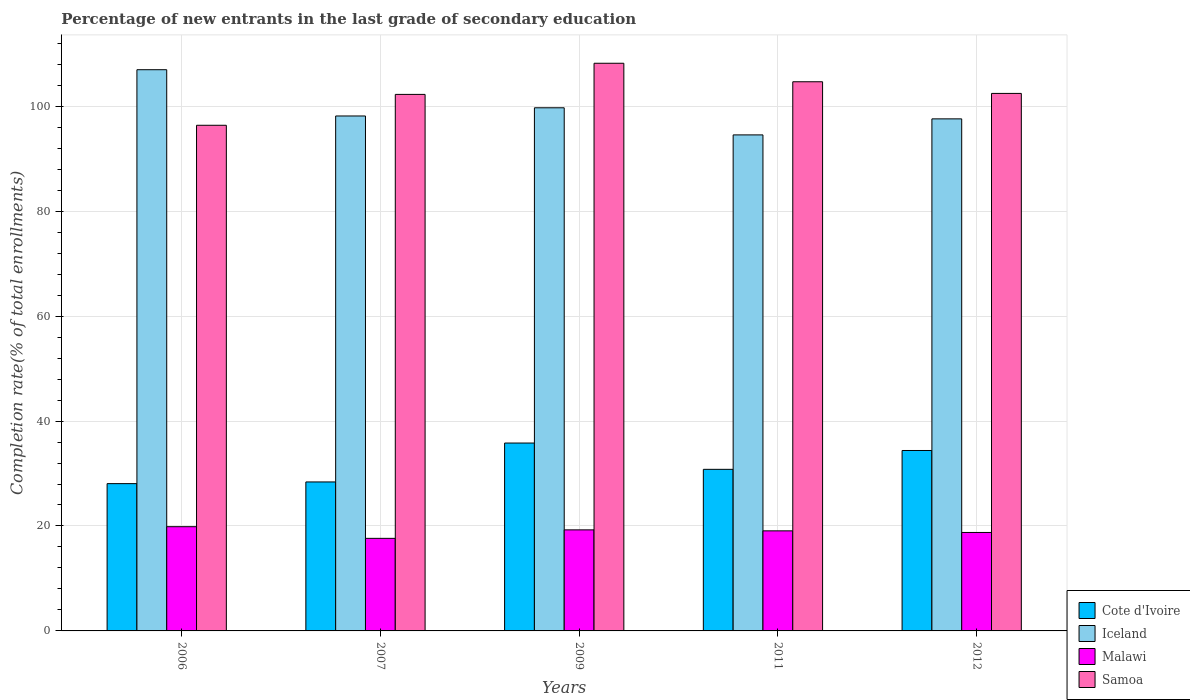How many groups of bars are there?
Offer a very short reply. 5. How many bars are there on the 4th tick from the left?
Your answer should be very brief. 4. What is the label of the 3rd group of bars from the left?
Keep it short and to the point. 2009. What is the percentage of new entrants in Iceland in 2006?
Your answer should be very brief. 106.96. Across all years, what is the maximum percentage of new entrants in Cote d'Ivoire?
Your answer should be very brief. 35.81. Across all years, what is the minimum percentage of new entrants in Malawi?
Your answer should be compact. 17.64. In which year was the percentage of new entrants in Cote d'Ivoire maximum?
Keep it short and to the point. 2009. What is the total percentage of new entrants in Malawi in the graph?
Offer a terse response. 94.61. What is the difference between the percentage of new entrants in Iceland in 2006 and that in 2007?
Offer a terse response. 8.82. What is the difference between the percentage of new entrants in Iceland in 2007 and the percentage of new entrants in Cote d'Ivoire in 2012?
Your answer should be compact. 63.76. What is the average percentage of new entrants in Samoa per year?
Give a very brief answer. 102.79. In the year 2009, what is the difference between the percentage of new entrants in Samoa and percentage of new entrants in Malawi?
Keep it short and to the point. 88.93. In how many years, is the percentage of new entrants in Cote d'Ivoire greater than 88 %?
Your answer should be very brief. 0. What is the ratio of the percentage of new entrants in Malawi in 2006 to that in 2007?
Offer a terse response. 1.13. Is the percentage of new entrants in Samoa in 2006 less than that in 2007?
Make the answer very short. Yes. What is the difference between the highest and the second highest percentage of new entrants in Cote d'Ivoire?
Ensure brevity in your answer.  1.42. What is the difference between the highest and the lowest percentage of new entrants in Iceland?
Make the answer very short. 12.42. What does the 3rd bar from the left in 2006 represents?
Provide a succinct answer. Malawi. What does the 4th bar from the right in 2007 represents?
Ensure brevity in your answer.  Cote d'Ivoire. Is it the case that in every year, the sum of the percentage of new entrants in Iceland and percentage of new entrants in Malawi is greater than the percentage of new entrants in Samoa?
Offer a terse response. Yes. How many bars are there?
Provide a succinct answer. 20. Are all the bars in the graph horizontal?
Make the answer very short. No. How many years are there in the graph?
Make the answer very short. 5. Are the values on the major ticks of Y-axis written in scientific E-notation?
Offer a very short reply. No. Does the graph contain grids?
Make the answer very short. Yes. Where does the legend appear in the graph?
Offer a very short reply. Bottom right. What is the title of the graph?
Keep it short and to the point. Percentage of new entrants in the last grade of secondary education. Does "Paraguay" appear as one of the legend labels in the graph?
Make the answer very short. No. What is the label or title of the X-axis?
Offer a very short reply. Years. What is the label or title of the Y-axis?
Your response must be concise. Completion rate(% of total enrollments). What is the Completion rate(% of total enrollments) in Cote d'Ivoire in 2006?
Offer a terse response. 28.07. What is the Completion rate(% of total enrollments) of Iceland in 2006?
Your response must be concise. 106.96. What is the Completion rate(% of total enrollments) in Malawi in 2006?
Give a very brief answer. 19.86. What is the Completion rate(% of total enrollments) in Samoa in 2006?
Provide a short and direct response. 96.37. What is the Completion rate(% of total enrollments) in Cote d'Ivoire in 2007?
Ensure brevity in your answer.  28.39. What is the Completion rate(% of total enrollments) of Iceland in 2007?
Offer a terse response. 98.14. What is the Completion rate(% of total enrollments) in Malawi in 2007?
Offer a very short reply. 17.64. What is the Completion rate(% of total enrollments) of Samoa in 2007?
Provide a succinct answer. 102.26. What is the Completion rate(% of total enrollments) of Cote d'Ivoire in 2009?
Give a very brief answer. 35.81. What is the Completion rate(% of total enrollments) of Iceland in 2009?
Make the answer very short. 99.7. What is the Completion rate(% of total enrollments) of Malawi in 2009?
Your answer should be very brief. 19.26. What is the Completion rate(% of total enrollments) of Samoa in 2009?
Offer a terse response. 108.19. What is the Completion rate(% of total enrollments) in Cote d'Ivoire in 2011?
Keep it short and to the point. 30.8. What is the Completion rate(% of total enrollments) of Iceland in 2011?
Offer a terse response. 94.54. What is the Completion rate(% of total enrollments) in Malawi in 2011?
Ensure brevity in your answer.  19.07. What is the Completion rate(% of total enrollments) in Samoa in 2011?
Offer a terse response. 104.66. What is the Completion rate(% of total enrollments) in Cote d'Ivoire in 2012?
Your answer should be compact. 34.39. What is the Completion rate(% of total enrollments) in Iceland in 2012?
Offer a terse response. 97.59. What is the Completion rate(% of total enrollments) of Malawi in 2012?
Provide a succinct answer. 18.77. What is the Completion rate(% of total enrollments) in Samoa in 2012?
Your answer should be compact. 102.44. Across all years, what is the maximum Completion rate(% of total enrollments) of Cote d'Ivoire?
Provide a short and direct response. 35.81. Across all years, what is the maximum Completion rate(% of total enrollments) of Iceland?
Your response must be concise. 106.96. Across all years, what is the maximum Completion rate(% of total enrollments) in Malawi?
Offer a terse response. 19.86. Across all years, what is the maximum Completion rate(% of total enrollments) of Samoa?
Provide a short and direct response. 108.19. Across all years, what is the minimum Completion rate(% of total enrollments) of Cote d'Ivoire?
Offer a terse response. 28.07. Across all years, what is the minimum Completion rate(% of total enrollments) of Iceland?
Provide a succinct answer. 94.54. Across all years, what is the minimum Completion rate(% of total enrollments) of Malawi?
Offer a terse response. 17.64. Across all years, what is the minimum Completion rate(% of total enrollments) in Samoa?
Provide a succinct answer. 96.37. What is the total Completion rate(% of total enrollments) of Cote d'Ivoire in the graph?
Provide a short and direct response. 157.46. What is the total Completion rate(% of total enrollments) in Iceland in the graph?
Provide a short and direct response. 496.94. What is the total Completion rate(% of total enrollments) of Malawi in the graph?
Give a very brief answer. 94.61. What is the total Completion rate(% of total enrollments) in Samoa in the graph?
Your answer should be very brief. 513.93. What is the difference between the Completion rate(% of total enrollments) of Cote d'Ivoire in 2006 and that in 2007?
Your answer should be very brief. -0.32. What is the difference between the Completion rate(% of total enrollments) in Iceland in 2006 and that in 2007?
Your response must be concise. 8.82. What is the difference between the Completion rate(% of total enrollments) of Malawi in 2006 and that in 2007?
Make the answer very short. 2.22. What is the difference between the Completion rate(% of total enrollments) in Samoa in 2006 and that in 2007?
Offer a very short reply. -5.88. What is the difference between the Completion rate(% of total enrollments) in Cote d'Ivoire in 2006 and that in 2009?
Your response must be concise. -7.74. What is the difference between the Completion rate(% of total enrollments) in Iceland in 2006 and that in 2009?
Provide a short and direct response. 7.26. What is the difference between the Completion rate(% of total enrollments) of Malawi in 2006 and that in 2009?
Your response must be concise. 0.6. What is the difference between the Completion rate(% of total enrollments) in Samoa in 2006 and that in 2009?
Offer a very short reply. -11.82. What is the difference between the Completion rate(% of total enrollments) in Cote d'Ivoire in 2006 and that in 2011?
Provide a succinct answer. -2.73. What is the difference between the Completion rate(% of total enrollments) in Iceland in 2006 and that in 2011?
Give a very brief answer. 12.42. What is the difference between the Completion rate(% of total enrollments) of Malawi in 2006 and that in 2011?
Offer a terse response. 0.79. What is the difference between the Completion rate(% of total enrollments) in Samoa in 2006 and that in 2011?
Ensure brevity in your answer.  -8.29. What is the difference between the Completion rate(% of total enrollments) in Cote d'Ivoire in 2006 and that in 2012?
Provide a short and direct response. -6.32. What is the difference between the Completion rate(% of total enrollments) of Iceland in 2006 and that in 2012?
Offer a very short reply. 9.37. What is the difference between the Completion rate(% of total enrollments) in Malawi in 2006 and that in 2012?
Ensure brevity in your answer.  1.1. What is the difference between the Completion rate(% of total enrollments) in Samoa in 2006 and that in 2012?
Your answer should be compact. -6.07. What is the difference between the Completion rate(% of total enrollments) of Cote d'Ivoire in 2007 and that in 2009?
Make the answer very short. -7.41. What is the difference between the Completion rate(% of total enrollments) of Iceland in 2007 and that in 2009?
Your answer should be very brief. -1.56. What is the difference between the Completion rate(% of total enrollments) in Malawi in 2007 and that in 2009?
Keep it short and to the point. -1.62. What is the difference between the Completion rate(% of total enrollments) of Samoa in 2007 and that in 2009?
Make the answer very short. -5.94. What is the difference between the Completion rate(% of total enrollments) of Cote d'Ivoire in 2007 and that in 2011?
Make the answer very short. -2.4. What is the difference between the Completion rate(% of total enrollments) of Iceland in 2007 and that in 2011?
Your answer should be very brief. 3.61. What is the difference between the Completion rate(% of total enrollments) in Malawi in 2007 and that in 2011?
Give a very brief answer. -1.43. What is the difference between the Completion rate(% of total enrollments) in Samoa in 2007 and that in 2011?
Make the answer very short. -2.41. What is the difference between the Completion rate(% of total enrollments) of Cote d'Ivoire in 2007 and that in 2012?
Your response must be concise. -5.99. What is the difference between the Completion rate(% of total enrollments) of Iceland in 2007 and that in 2012?
Your answer should be very brief. 0.55. What is the difference between the Completion rate(% of total enrollments) in Malawi in 2007 and that in 2012?
Provide a short and direct response. -1.12. What is the difference between the Completion rate(% of total enrollments) in Samoa in 2007 and that in 2012?
Provide a succinct answer. -0.19. What is the difference between the Completion rate(% of total enrollments) of Cote d'Ivoire in 2009 and that in 2011?
Offer a terse response. 5.01. What is the difference between the Completion rate(% of total enrollments) in Iceland in 2009 and that in 2011?
Provide a succinct answer. 5.17. What is the difference between the Completion rate(% of total enrollments) of Malawi in 2009 and that in 2011?
Your response must be concise. 0.19. What is the difference between the Completion rate(% of total enrollments) in Samoa in 2009 and that in 2011?
Your response must be concise. 3.53. What is the difference between the Completion rate(% of total enrollments) of Cote d'Ivoire in 2009 and that in 2012?
Provide a short and direct response. 1.42. What is the difference between the Completion rate(% of total enrollments) in Iceland in 2009 and that in 2012?
Your answer should be compact. 2.11. What is the difference between the Completion rate(% of total enrollments) in Malawi in 2009 and that in 2012?
Your answer should be very brief. 0.49. What is the difference between the Completion rate(% of total enrollments) of Samoa in 2009 and that in 2012?
Your response must be concise. 5.75. What is the difference between the Completion rate(% of total enrollments) of Cote d'Ivoire in 2011 and that in 2012?
Keep it short and to the point. -3.59. What is the difference between the Completion rate(% of total enrollments) in Iceland in 2011 and that in 2012?
Your response must be concise. -3.06. What is the difference between the Completion rate(% of total enrollments) of Malawi in 2011 and that in 2012?
Your answer should be very brief. 0.31. What is the difference between the Completion rate(% of total enrollments) in Samoa in 2011 and that in 2012?
Provide a short and direct response. 2.22. What is the difference between the Completion rate(% of total enrollments) of Cote d'Ivoire in 2006 and the Completion rate(% of total enrollments) of Iceland in 2007?
Your answer should be compact. -70.07. What is the difference between the Completion rate(% of total enrollments) of Cote d'Ivoire in 2006 and the Completion rate(% of total enrollments) of Malawi in 2007?
Offer a terse response. 10.43. What is the difference between the Completion rate(% of total enrollments) in Cote d'Ivoire in 2006 and the Completion rate(% of total enrollments) in Samoa in 2007?
Your answer should be very brief. -74.18. What is the difference between the Completion rate(% of total enrollments) of Iceland in 2006 and the Completion rate(% of total enrollments) of Malawi in 2007?
Keep it short and to the point. 89.32. What is the difference between the Completion rate(% of total enrollments) of Iceland in 2006 and the Completion rate(% of total enrollments) of Samoa in 2007?
Provide a short and direct response. 4.7. What is the difference between the Completion rate(% of total enrollments) of Malawi in 2006 and the Completion rate(% of total enrollments) of Samoa in 2007?
Offer a very short reply. -82.39. What is the difference between the Completion rate(% of total enrollments) in Cote d'Ivoire in 2006 and the Completion rate(% of total enrollments) in Iceland in 2009?
Provide a short and direct response. -71.63. What is the difference between the Completion rate(% of total enrollments) of Cote d'Ivoire in 2006 and the Completion rate(% of total enrollments) of Malawi in 2009?
Your answer should be compact. 8.81. What is the difference between the Completion rate(% of total enrollments) of Cote d'Ivoire in 2006 and the Completion rate(% of total enrollments) of Samoa in 2009?
Give a very brief answer. -80.12. What is the difference between the Completion rate(% of total enrollments) in Iceland in 2006 and the Completion rate(% of total enrollments) in Malawi in 2009?
Your answer should be very brief. 87.7. What is the difference between the Completion rate(% of total enrollments) of Iceland in 2006 and the Completion rate(% of total enrollments) of Samoa in 2009?
Offer a terse response. -1.23. What is the difference between the Completion rate(% of total enrollments) of Malawi in 2006 and the Completion rate(% of total enrollments) of Samoa in 2009?
Your answer should be very brief. -88.33. What is the difference between the Completion rate(% of total enrollments) of Cote d'Ivoire in 2006 and the Completion rate(% of total enrollments) of Iceland in 2011?
Provide a succinct answer. -66.46. What is the difference between the Completion rate(% of total enrollments) in Cote d'Ivoire in 2006 and the Completion rate(% of total enrollments) in Malawi in 2011?
Provide a succinct answer. 9. What is the difference between the Completion rate(% of total enrollments) of Cote d'Ivoire in 2006 and the Completion rate(% of total enrollments) of Samoa in 2011?
Offer a terse response. -76.59. What is the difference between the Completion rate(% of total enrollments) of Iceland in 2006 and the Completion rate(% of total enrollments) of Malawi in 2011?
Your answer should be very brief. 87.89. What is the difference between the Completion rate(% of total enrollments) of Iceland in 2006 and the Completion rate(% of total enrollments) of Samoa in 2011?
Offer a terse response. 2.3. What is the difference between the Completion rate(% of total enrollments) of Malawi in 2006 and the Completion rate(% of total enrollments) of Samoa in 2011?
Your answer should be compact. -84.8. What is the difference between the Completion rate(% of total enrollments) of Cote d'Ivoire in 2006 and the Completion rate(% of total enrollments) of Iceland in 2012?
Provide a succinct answer. -69.52. What is the difference between the Completion rate(% of total enrollments) of Cote d'Ivoire in 2006 and the Completion rate(% of total enrollments) of Malawi in 2012?
Your response must be concise. 9.31. What is the difference between the Completion rate(% of total enrollments) of Cote d'Ivoire in 2006 and the Completion rate(% of total enrollments) of Samoa in 2012?
Provide a short and direct response. -74.37. What is the difference between the Completion rate(% of total enrollments) of Iceland in 2006 and the Completion rate(% of total enrollments) of Malawi in 2012?
Your response must be concise. 88.19. What is the difference between the Completion rate(% of total enrollments) in Iceland in 2006 and the Completion rate(% of total enrollments) in Samoa in 2012?
Your answer should be very brief. 4.52. What is the difference between the Completion rate(% of total enrollments) of Malawi in 2006 and the Completion rate(% of total enrollments) of Samoa in 2012?
Your response must be concise. -82.58. What is the difference between the Completion rate(% of total enrollments) in Cote d'Ivoire in 2007 and the Completion rate(% of total enrollments) in Iceland in 2009?
Ensure brevity in your answer.  -71.31. What is the difference between the Completion rate(% of total enrollments) of Cote d'Ivoire in 2007 and the Completion rate(% of total enrollments) of Malawi in 2009?
Keep it short and to the point. 9.13. What is the difference between the Completion rate(% of total enrollments) in Cote d'Ivoire in 2007 and the Completion rate(% of total enrollments) in Samoa in 2009?
Your answer should be compact. -79.8. What is the difference between the Completion rate(% of total enrollments) of Iceland in 2007 and the Completion rate(% of total enrollments) of Malawi in 2009?
Keep it short and to the point. 78.88. What is the difference between the Completion rate(% of total enrollments) of Iceland in 2007 and the Completion rate(% of total enrollments) of Samoa in 2009?
Ensure brevity in your answer.  -10.05. What is the difference between the Completion rate(% of total enrollments) in Malawi in 2007 and the Completion rate(% of total enrollments) in Samoa in 2009?
Your response must be concise. -90.55. What is the difference between the Completion rate(% of total enrollments) in Cote d'Ivoire in 2007 and the Completion rate(% of total enrollments) in Iceland in 2011?
Ensure brevity in your answer.  -66.14. What is the difference between the Completion rate(% of total enrollments) in Cote d'Ivoire in 2007 and the Completion rate(% of total enrollments) in Malawi in 2011?
Give a very brief answer. 9.32. What is the difference between the Completion rate(% of total enrollments) of Cote d'Ivoire in 2007 and the Completion rate(% of total enrollments) of Samoa in 2011?
Your answer should be compact. -76.27. What is the difference between the Completion rate(% of total enrollments) of Iceland in 2007 and the Completion rate(% of total enrollments) of Malawi in 2011?
Keep it short and to the point. 79.07. What is the difference between the Completion rate(% of total enrollments) of Iceland in 2007 and the Completion rate(% of total enrollments) of Samoa in 2011?
Give a very brief answer. -6.52. What is the difference between the Completion rate(% of total enrollments) of Malawi in 2007 and the Completion rate(% of total enrollments) of Samoa in 2011?
Keep it short and to the point. -87.02. What is the difference between the Completion rate(% of total enrollments) of Cote d'Ivoire in 2007 and the Completion rate(% of total enrollments) of Iceland in 2012?
Your response must be concise. -69.2. What is the difference between the Completion rate(% of total enrollments) of Cote d'Ivoire in 2007 and the Completion rate(% of total enrollments) of Malawi in 2012?
Your answer should be compact. 9.63. What is the difference between the Completion rate(% of total enrollments) of Cote d'Ivoire in 2007 and the Completion rate(% of total enrollments) of Samoa in 2012?
Ensure brevity in your answer.  -74.05. What is the difference between the Completion rate(% of total enrollments) of Iceland in 2007 and the Completion rate(% of total enrollments) of Malawi in 2012?
Your response must be concise. 79.38. What is the difference between the Completion rate(% of total enrollments) of Iceland in 2007 and the Completion rate(% of total enrollments) of Samoa in 2012?
Your answer should be compact. -4.3. What is the difference between the Completion rate(% of total enrollments) of Malawi in 2007 and the Completion rate(% of total enrollments) of Samoa in 2012?
Your answer should be compact. -84.8. What is the difference between the Completion rate(% of total enrollments) of Cote d'Ivoire in 2009 and the Completion rate(% of total enrollments) of Iceland in 2011?
Provide a short and direct response. -58.73. What is the difference between the Completion rate(% of total enrollments) in Cote d'Ivoire in 2009 and the Completion rate(% of total enrollments) in Malawi in 2011?
Give a very brief answer. 16.74. What is the difference between the Completion rate(% of total enrollments) of Cote d'Ivoire in 2009 and the Completion rate(% of total enrollments) of Samoa in 2011?
Your answer should be compact. -68.86. What is the difference between the Completion rate(% of total enrollments) of Iceland in 2009 and the Completion rate(% of total enrollments) of Malawi in 2011?
Provide a succinct answer. 80.63. What is the difference between the Completion rate(% of total enrollments) in Iceland in 2009 and the Completion rate(% of total enrollments) in Samoa in 2011?
Give a very brief answer. -4.96. What is the difference between the Completion rate(% of total enrollments) in Malawi in 2009 and the Completion rate(% of total enrollments) in Samoa in 2011?
Your answer should be compact. -85.4. What is the difference between the Completion rate(% of total enrollments) of Cote d'Ivoire in 2009 and the Completion rate(% of total enrollments) of Iceland in 2012?
Offer a terse response. -61.78. What is the difference between the Completion rate(% of total enrollments) in Cote d'Ivoire in 2009 and the Completion rate(% of total enrollments) in Malawi in 2012?
Give a very brief answer. 17.04. What is the difference between the Completion rate(% of total enrollments) of Cote d'Ivoire in 2009 and the Completion rate(% of total enrollments) of Samoa in 2012?
Keep it short and to the point. -66.63. What is the difference between the Completion rate(% of total enrollments) in Iceland in 2009 and the Completion rate(% of total enrollments) in Malawi in 2012?
Keep it short and to the point. 80.94. What is the difference between the Completion rate(% of total enrollments) of Iceland in 2009 and the Completion rate(% of total enrollments) of Samoa in 2012?
Your answer should be very brief. -2.74. What is the difference between the Completion rate(% of total enrollments) in Malawi in 2009 and the Completion rate(% of total enrollments) in Samoa in 2012?
Your answer should be compact. -83.18. What is the difference between the Completion rate(% of total enrollments) of Cote d'Ivoire in 2011 and the Completion rate(% of total enrollments) of Iceland in 2012?
Ensure brevity in your answer.  -66.8. What is the difference between the Completion rate(% of total enrollments) of Cote d'Ivoire in 2011 and the Completion rate(% of total enrollments) of Malawi in 2012?
Give a very brief answer. 12.03. What is the difference between the Completion rate(% of total enrollments) in Cote d'Ivoire in 2011 and the Completion rate(% of total enrollments) in Samoa in 2012?
Give a very brief answer. -71.65. What is the difference between the Completion rate(% of total enrollments) of Iceland in 2011 and the Completion rate(% of total enrollments) of Malawi in 2012?
Give a very brief answer. 75.77. What is the difference between the Completion rate(% of total enrollments) of Iceland in 2011 and the Completion rate(% of total enrollments) of Samoa in 2012?
Offer a terse response. -7.91. What is the difference between the Completion rate(% of total enrollments) of Malawi in 2011 and the Completion rate(% of total enrollments) of Samoa in 2012?
Give a very brief answer. -83.37. What is the average Completion rate(% of total enrollments) in Cote d'Ivoire per year?
Offer a very short reply. 31.49. What is the average Completion rate(% of total enrollments) in Iceland per year?
Make the answer very short. 99.39. What is the average Completion rate(% of total enrollments) of Malawi per year?
Give a very brief answer. 18.92. What is the average Completion rate(% of total enrollments) of Samoa per year?
Offer a terse response. 102.79. In the year 2006, what is the difference between the Completion rate(% of total enrollments) in Cote d'Ivoire and Completion rate(% of total enrollments) in Iceland?
Your response must be concise. -78.89. In the year 2006, what is the difference between the Completion rate(% of total enrollments) of Cote d'Ivoire and Completion rate(% of total enrollments) of Malawi?
Offer a terse response. 8.21. In the year 2006, what is the difference between the Completion rate(% of total enrollments) in Cote d'Ivoire and Completion rate(% of total enrollments) in Samoa?
Keep it short and to the point. -68.3. In the year 2006, what is the difference between the Completion rate(% of total enrollments) of Iceland and Completion rate(% of total enrollments) of Malawi?
Ensure brevity in your answer.  87.1. In the year 2006, what is the difference between the Completion rate(% of total enrollments) in Iceland and Completion rate(% of total enrollments) in Samoa?
Your answer should be compact. 10.59. In the year 2006, what is the difference between the Completion rate(% of total enrollments) of Malawi and Completion rate(% of total enrollments) of Samoa?
Give a very brief answer. -76.51. In the year 2007, what is the difference between the Completion rate(% of total enrollments) in Cote d'Ivoire and Completion rate(% of total enrollments) in Iceland?
Provide a short and direct response. -69.75. In the year 2007, what is the difference between the Completion rate(% of total enrollments) in Cote d'Ivoire and Completion rate(% of total enrollments) in Malawi?
Provide a succinct answer. 10.75. In the year 2007, what is the difference between the Completion rate(% of total enrollments) in Cote d'Ivoire and Completion rate(% of total enrollments) in Samoa?
Provide a short and direct response. -73.86. In the year 2007, what is the difference between the Completion rate(% of total enrollments) in Iceland and Completion rate(% of total enrollments) in Malawi?
Ensure brevity in your answer.  80.5. In the year 2007, what is the difference between the Completion rate(% of total enrollments) of Iceland and Completion rate(% of total enrollments) of Samoa?
Offer a terse response. -4.11. In the year 2007, what is the difference between the Completion rate(% of total enrollments) in Malawi and Completion rate(% of total enrollments) in Samoa?
Provide a succinct answer. -84.61. In the year 2009, what is the difference between the Completion rate(% of total enrollments) in Cote d'Ivoire and Completion rate(% of total enrollments) in Iceland?
Offer a terse response. -63.89. In the year 2009, what is the difference between the Completion rate(% of total enrollments) in Cote d'Ivoire and Completion rate(% of total enrollments) in Malawi?
Give a very brief answer. 16.55. In the year 2009, what is the difference between the Completion rate(% of total enrollments) in Cote d'Ivoire and Completion rate(% of total enrollments) in Samoa?
Provide a succinct answer. -72.38. In the year 2009, what is the difference between the Completion rate(% of total enrollments) in Iceland and Completion rate(% of total enrollments) in Malawi?
Your response must be concise. 80.44. In the year 2009, what is the difference between the Completion rate(% of total enrollments) of Iceland and Completion rate(% of total enrollments) of Samoa?
Provide a succinct answer. -8.49. In the year 2009, what is the difference between the Completion rate(% of total enrollments) of Malawi and Completion rate(% of total enrollments) of Samoa?
Provide a short and direct response. -88.93. In the year 2011, what is the difference between the Completion rate(% of total enrollments) in Cote d'Ivoire and Completion rate(% of total enrollments) in Iceland?
Offer a very short reply. -63.74. In the year 2011, what is the difference between the Completion rate(% of total enrollments) of Cote d'Ivoire and Completion rate(% of total enrollments) of Malawi?
Offer a very short reply. 11.72. In the year 2011, what is the difference between the Completion rate(% of total enrollments) in Cote d'Ivoire and Completion rate(% of total enrollments) in Samoa?
Ensure brevity in your answer.  -73.87. In the year 2011, what is the difference between the Completion rate(% of total enrollments) of Iceland and Completion rate(% of total enrollments) of Malawi?
Provide a short and direct response. 75.46. In the year 2011, what is the difference between the Completion rate(% of total enrollments) of Iceland and Completion rate(% of total enrollments) of Samoa?
Your answer should be very brief. -10.13. In the year 2011, what is the difference between the Completion rate(% of total enrollments) in Malawi and Completion rate(% of total enrollments) in Samoa?
Your response must be concise. -85.59. In the year 2012, what is the difference between the Completion rate(% of total enrollments) of Cote d'Ivoire and Completion rate(% of total enrollments) of Iceland?
Offer a terse response. -63.21. In the year 2012, what is the difference between the Completion rate(% of total enrollments) of Cote d'Ivoire and Completion rate(% of total enrollments) of Malawi?
Give a very brief answer. 15.62. In the year 2012, what is the difference between the Completion rate(% of total enrollments) of Cote d'Ivoire and Completion rate(% of total enrollments) of Samoa?
Give a very brief answer. -68.06. In the year 2012, what is the difference between the Completion rate(% of total enrollments) of Iceland and Completion rate(% of total enrollments) of Malawi?
Provide a short and direct response. 78.83. In the year 2012, what is the difference between the Completion rate(% of total enrollments) in Iceland and Completion rate(% of total enrollments) in Samoa?
Provide a short and direct response. -4.85. In the year 2012, what is the difference between the Completion rate(% of total enrollments) in Malawi and Completion rate(% of total enrollments) in Samoa?
Give a very brief answer. -83.68. What is the ratio of the Completion rate(% of total enrollments) in Cote d'Ivoire in 2006 to that in 2007?
Make the answer very short. 0.99. What is the ratio of the Completion rate(% of total enrollments) of Iceland in 2006 to that in 2007?
Your answer should be compact. 1.09. What is the ratio of the Completion rate(% of total enrollments) of Malawi in 2006 to that in 2007?
Ensure brevity in your answer.  1.13. What is the ratio of the Completion rate(% of total enrollments) of Samoa in 2006 to that in 2007?
Ensure brevity in your answer.  0.94. What is the ratio of the Completion rate(% of total enrollments) in Cote d'Ivoire in 2006 to that in 2009?
Keep it short and to the point. 0.78. What is the ratio of the Completion rate(% of total enrollments) of Iceland in 2006 to that in 2009?
Offer a very short reply. 1.07. What is the ratio of the Completion rate(% of total enrollments) in Malawi in 2006 to that in 2009?
Offer a very short reply. 1.03. What is the ratio of the Completion rate(% of total enrollments) of Samoa in 2006 to that in 2009?
Give a very brief answer. 0.89. What is the ratio of the Completion rate(% of total enrollments) in Cote d'Ivoire in 2006 to that in 2011?
Your response must be concise. 0.91. What is the ratio of the Completion rate(% of total enrollments) of Iceland in 2006 to that in 2011?
Your response must be concise. 1.13. What is the ratio of the Completion rate(% of total enrollments) in Malawi in 2006 to that in 2011?
Your answer should be compact. 1.04. What is the ratio of the Completion rate(% of total enrollments) of Samoa in 2006 to that in 2011?
Provide a succinct answer. 0.92. What is the ratio of the Completion rate(% of total enrollments) of Cote d'Ivoire in 2006 to that in 2012?
Keep it short and to the point. 0.82. What is the ratio of the Completion rate(% of total enrollments) of Iceland in 2006 to that in 2012?
Make the answer very short. 1.1. What is the ratio of the Completion rate(% of total enrollments) of Malawi in 2006 to that in 2012?
Make the answer very short. 1.06. What is the ratio of the Completion rate(% of total enrollments) in Samoa in 2006 to that in 2012?
Provide a short and direct response. 0.94. What is the ratio of the Completion rate(% of total enrollments) of Cote d'Ivoire in 2007 to that in 2009?
Offer a very short reply. 0.79. What is the ratio of the Completion rate(% of total enrollments) in Iceland in 2007 to that in 2009?
Your answer should be very brief. 0.98. What is the ratio of the Completion rate(% of total enrollments) of Malawi in 2007 to that in 2009?
Provide a short and direct response. 0.92. What is the ratio of the Completion rate(% of total enrollments) of Samoa in 2007 to that in 2009?
Make the answer very short. 0.95. What is the ratio of the Completion rate(% of total enrollments) in Cote d'Ivoire in 2007 to that in 2011?
Make the answer very short. 0.92. What is the ratio of the Completion rate(% of total enrollments) in Iceland in 2007 to that in 2011?
Give a very brief answer. 1.04. What is the ratio of the Completion rate(% of total enrollments) in Malawi in 2007 to that in 2011?
Your answer should be compact. 0.93. What is the ratio of the Completion rate(% of total enrollments) of Cote d'Ivoire in 2007 to that in 2012?
Your answer should be compact. 0.83. What is the ratio of the Completion rate(% of total enrollments) of Iceland in 2007 to that in 2012?
Offer a very short reply. 1.01. What is the ratio of the Completion rate(% of total enrollments) of Malawi in 2007 to that in 2012?
Your answer should be compact. 0.94. What is the ratio of the Completion rate(% of total enrollments) in Cote d'Ivoire in 2009 to that in 2011?
Offer a very short reply. 1.16. What is the ratio of the Completion rate(% of total enrollments) in Iceland in 2009 to that in 2011?
Make the answer very short. 1.05. What is the ratio of the Completion rate(% of total enrollments) of Malawi in 2009 to that in 2011?
Your answer should be very brief. 1.01. What is the ratio of the Completion rate(% of total enrollments) of Samoa in 2009 to that in 2011?
Your answer should be very brief. 1.03. What is the ratio of the Completion rate(% of total enrollments) in Cote d'Ivoire in 2009 to that in 2012?
Your answer should be compact. 1.04. What is the ratio of the Completion rate(% of total enrollments) of Iceland in 2009 to that in 2012?
Your response must be concise. 1.02. What is the ratio of the Completion rate(% of total enrollments) in Malawi in 2009 to that in 2012?
Provide a succinct answer. 1.03. What is the ratio of the Completion rate(% of total enrollments) of Samoa in 2009 to that in 2012?
Your response must be concise. 1.06. What is the ratio of the Completion rate(% of total enrollments) of Cote d'Ivoire in 2011 to that in 2012?
Make the answer very short. 0.9. What is the ratio of the Completion rate(% of total enrollments) in Iceland in 2011 to that in 2012?
Provide a succinct answer. 0.97. What is the ratio of the Completion rate(% of total enrollments) in Malawi in 2011 to that in 2012?
Give a very brief answer. 1.02. What is the ratio of the Completion rate(% of total enrollments) in Samoa in 2011 to that in 2012?
Offer a terse response. 1.02. What is the difference between the highest and the second highest Completion rate(% of total enrollments) in Cote d'Ivoire?
Provide a short and direct response. 1.42. What is the difference between the highest and the second highest Completion rate(% of total enrollments) of Iceland?
Your answer should be very brief. 7.26. What is the difference between the highest and the second highest Completion rate(% of total enrollments) of Malawi?
Provide a succinct answer. 0.6. What is the difference between the highest and the second highest Completion rate(% of total enrollments) of Samoa?
Keep it short and to the point. 3.53. What is the difference between the highest and the lowest Completion rate(% of total enrollments) in Cote d'Ivoire?
Give a very brief answer. 7.74. What is the difference between the highest and the lowest Completion rate(% of total enrollments) in Iceland?
Give a very brief answer. 12.42. What is the difference between the highest and the lowest Completion rate(% of total enrollments) of Malawi?
Your answer should be compact. 2.22. What is the difference between the highest and the lowest Completion rate(% of total enrollments) in Samoa?
Ensure brevity in your answer.  11.82. 